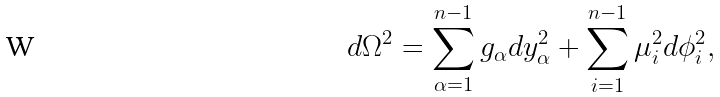<formula> <loc_0><loc_0><loc_500><loc_500>d \Omega ^ { 2 } = \sum _ { \alpha = 1 } ^ { n - 1 } g _ { \alpha } d y _ { \alpha } ^ { 2 } + \sum _ { i = 1 } ^ { n - 1 } \mu _ { i } ^ { 2 } d \phi _ { i } ^ { 2 } ,</formula> 